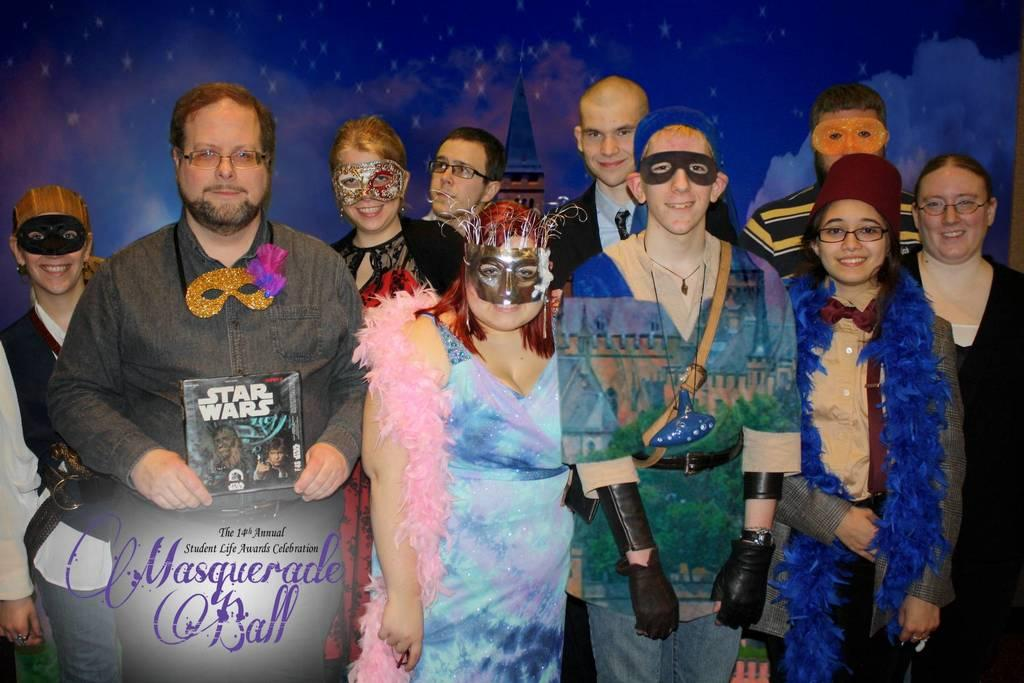What can be observed about the people in the image? There are people standing in the image, and they are wearing different color dresses. Can you describe what one person is holding? One person is holding something, but the specific object cannot be determined from the provided facts. What colors are present in the background of the image? The background of the image is blue and black in color. How many roses can be seen in the image? There are no roses present in the image. What type of lettuce is being used as a prop by one of the people in the image? There is no lettuce present in the image, and no one is using any prop. 